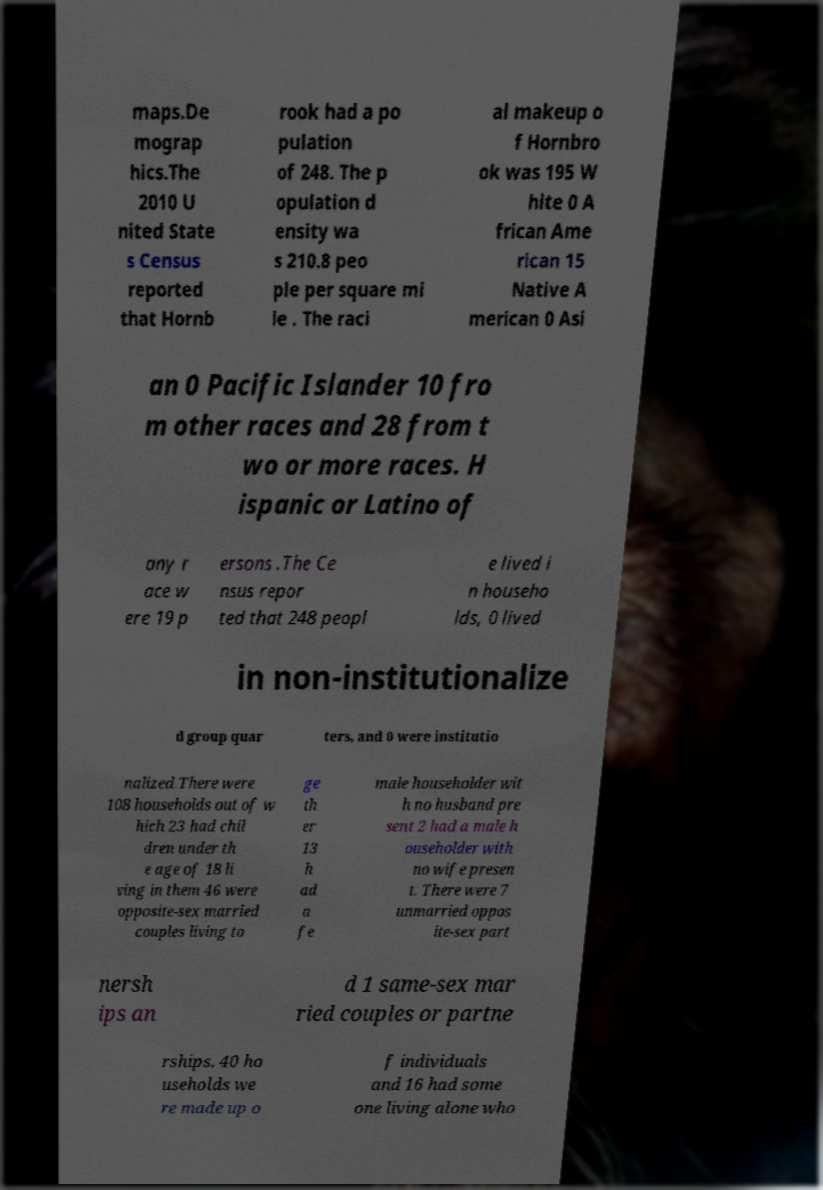Could you extract and type out the text from this image? maps.De mograp hics.The 2010 U nited State s Census reported that Hornb rook had a po pulation of 248. The p opulation d ensity wa s 210.8 peo ple per square mi le . The raci al makeup o f Hornbro ok was 195 W hite 0 A frican Ame rican 15 Native A merican 0 Asi an 0 Pacific Islander 10 fro m other races and 28 from t wo or more races. H ispanic or Latino of any r ace w ere 19 p ersons .The Ce nsus repor ted that 248 peopl e lived i n househo lds, 0 lived in non-institutionalize d group quar ters, and 0 were institutio nalized.There were 108 households out of w hich 23 had chil dren under th e age of 18 li ving in them 46 were opposite-sex married couples living to ge th er 13 h ad a fe male householder wit h no husband pre sent 2 had a male h ouseholder with no wife presen t. There were 7 unmarried oppos ite-sex part nersh ips an d 1 same-sex mar ried couples or partne rships. 40 ho useholds we re made up o f individuals and 16 had some one living alone who 